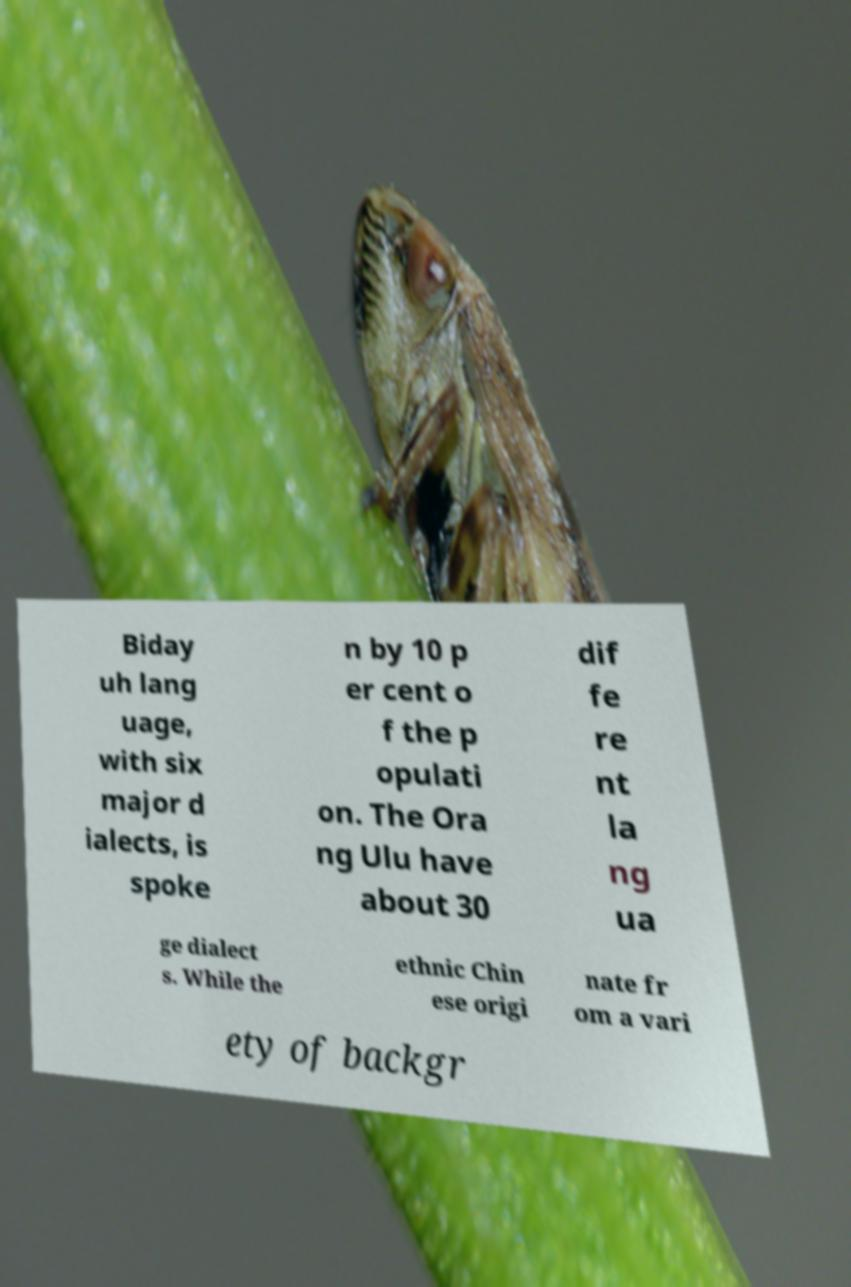For documentation purposes, I need the text within this image transcribed. Could you provide that? Biday uh lang uage, with six major d ialects, is spoke n by 10 p er cent o f the p opulati on. The Ora ng Ulu have about 30 dif fe re nt la ng ua ge dialect s. While the ethnic Chin ese origi nate fr om a vari ety of backgr 